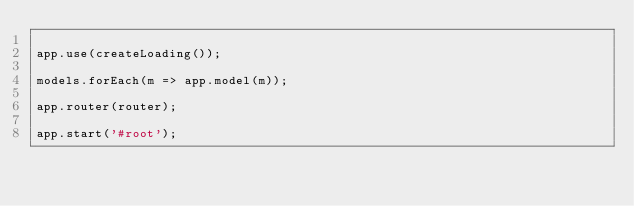Convert code to text. <code><loc_0><loc_0><loc_500><loc_500><_JavaScript_>
app.use(createLoading());

models.forEach(m => app.model(m));

app.router(router);

app.start('#root');
</code> 